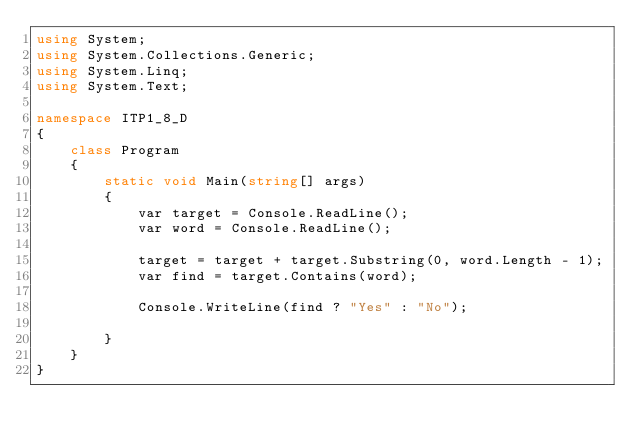Convert code to text. <code><loc_0><loc_0><loc_500><loc_500><_C#_>using System;
using System.Collections.Generic;
using System.Linq;
using System.Text;

namespace ITP1_8_D
{
    class Program
    {
        static void Main(string[] args)
        {
            var target = Console.ReadLine();
            var word = Console.ReadLine();

            target = target + target.Substring(0, word.Length - 1);
            var find = target.Contains(word);

            Console.WriteLine(find ? "Yes" : "No");
            
        }
    }
}</code> 